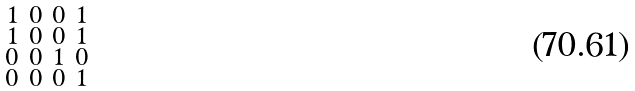<formula> <loc_0><loc_0><loc_500><loc_500>\begin{smallmatrix} 1 & 0 & 0 & 1 \\ 1 & 0 & 0 & 1 \\ 0 & 0 & 1 & 0 \\ 0 & 0 & 0 & 1 \\ \end{smallmatrix}</formula> 